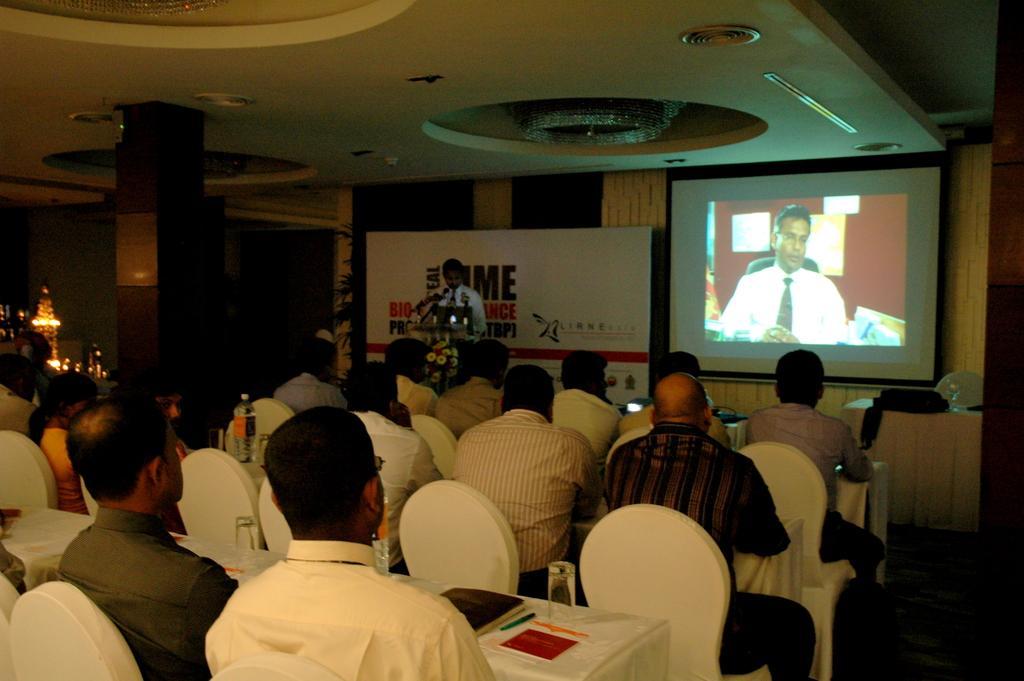How would you summarize this image in a sentence or two? There are few people sitting on the chairs at the table. On the table we can see water bottles,glasses,books,pen,papers and some other objects and we can also see lights on the left side,house plant. In the background we can see a screen,a person standing at the podium,hoarding and on the podium we can see microphones. On the roof top we can see the ceiling and lights and on the right there is a bag on a table. 